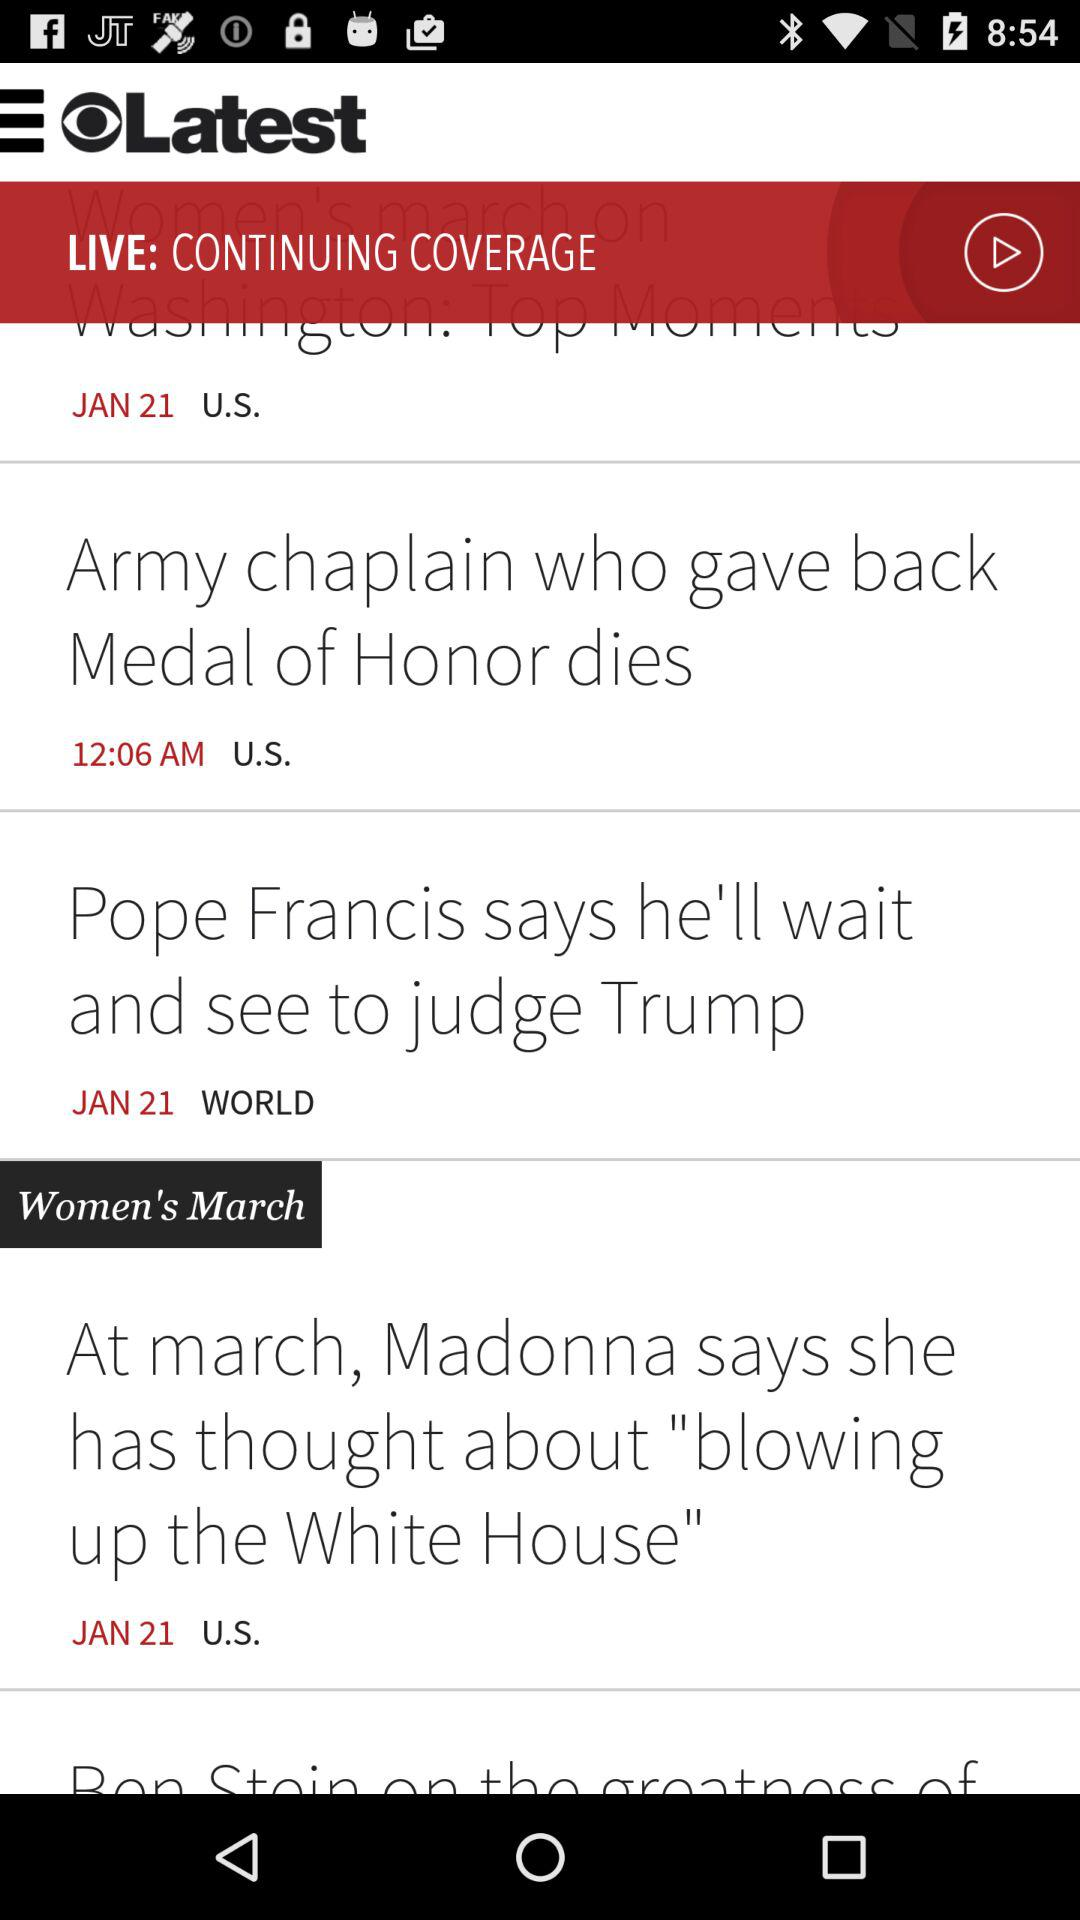What is the application name? The application name is "Latest". 